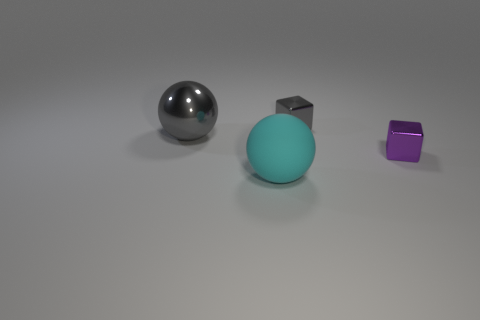What do the objects in the image tell us about their materials? The metallic sphere appears to be made of a polished metal due to its reflective surface, while the matte texture of the teal sphere suggests a surface with more diffuse reflectance, possibly plastic or ceramic. The cube, while small and purple, has a specular highlight indicating it might be a shiny or metallic material. 